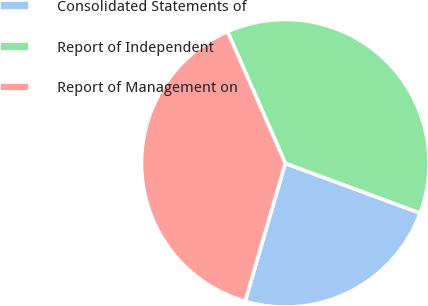Convert chart. <chart><loc_0><loc_0><loc_500><loc_500><pie_chart><fcel>Consolidated Statements of<fcel>Report of Independent<fcel>Report of Management on<nl><fcel>23.87%<fcel>37.21%<fcel>38.92%<nl></chart> 